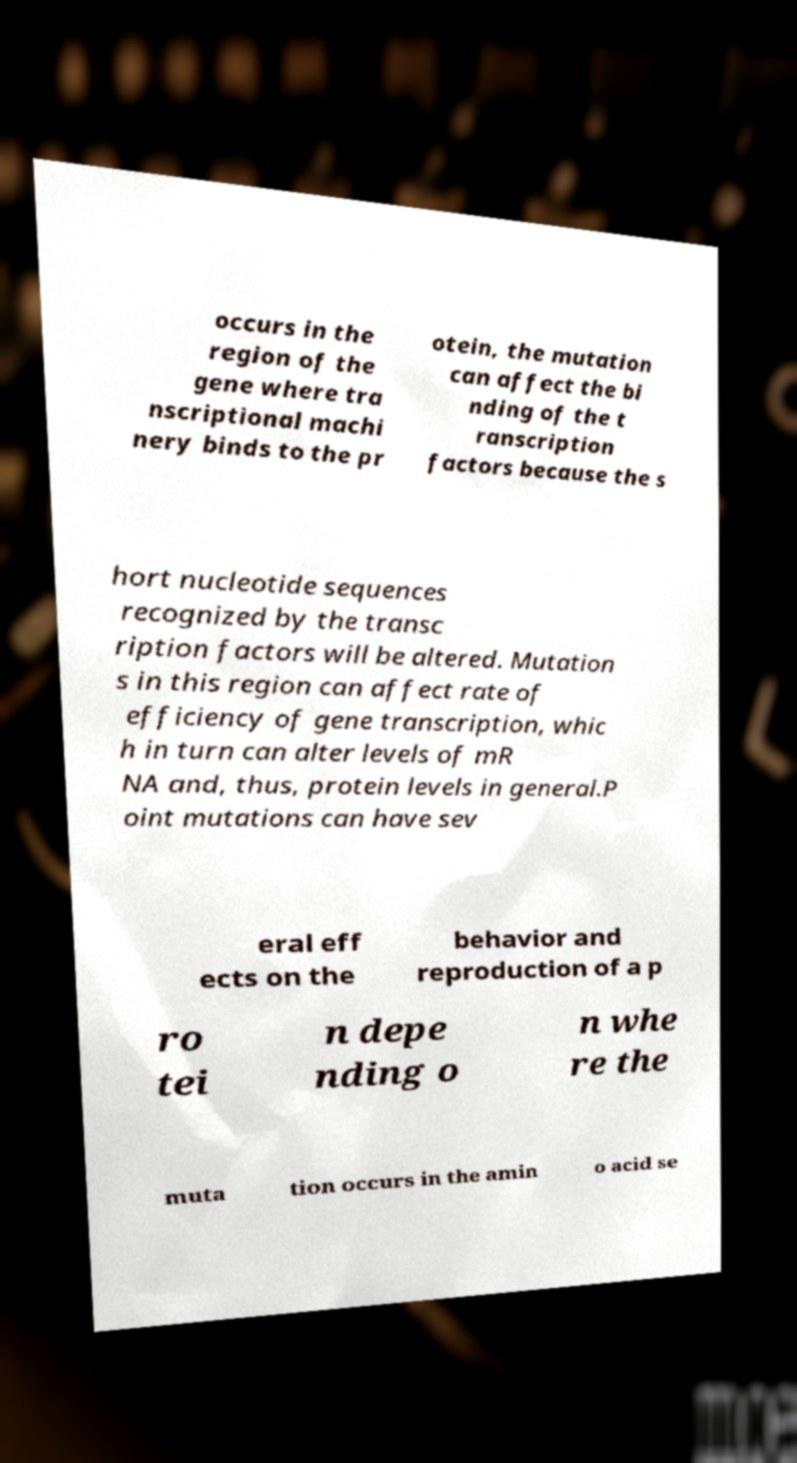Could you extract and type out the text from this image? occurs in the region of the gene where tra nscriptional machi nery binds to the pr otein, the mutation can affect the bi nding of the t ranscription factors because the s hort nucleotide sequences recognized by the transc ription factors will be altered. Mutation s in this region can affect rate of efficiency of gene transcription, whic h in turn can alter levels of mR NA and, thus, protein levels in general.P oint mutations can have sev eral eff ects on the behavior and reproduction of a p ro tei n depe nding o n whe re the muta tion occurs in the amin o acid se 